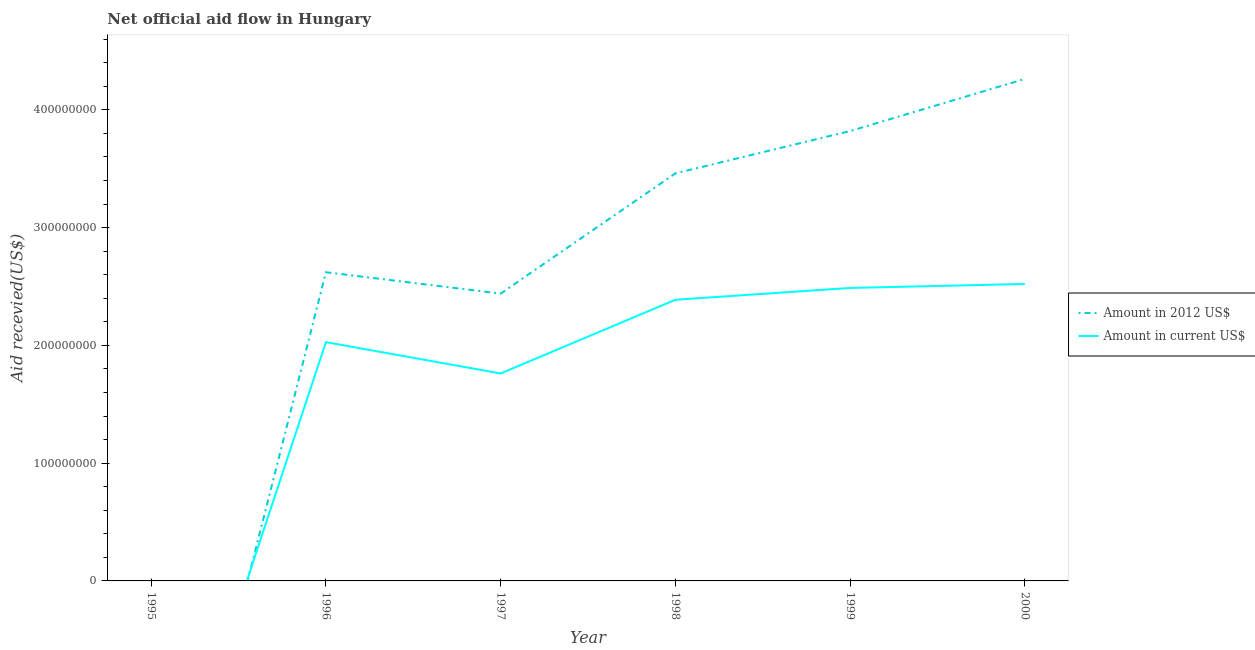How many different coloured lines are there?
Your answer should be very brief. 2. Does the line corresponding to amount of aid received(expressed in us$) intersect with the line corresponding to amount of aid received(expressed in 2012 us$)?
Keep it short and to the point. Yes. Is the number of lines equal to the number of legend labels?
Your answer should be very brief. No. What is the amount of aid received(expressed in us$) in 1999?
Offer a very short reply. 2.49e+08. Across all years, what is the maximum amount of aid received(expressed in 2012 us$)?
Give a very brief answer. 4.26e+08. In which year was the amount of aid received(expressed in us$) maximum?
Your answer should be compact. 2000. What is the total amount of aid received(expressed in 2012 us$) in the graph?
Your response must be concise. 1.66e+09. What is the difference between the amount of aid received(expressed in us$) in 1997 and that in 1999?
Your answer should be compact. -7.26e+07. What is the difference between the amount of aid received(expressed in 2012 us$) in 1997 and the amount of aid received(expressed in us$) in 2000?
Provide a short and direct response. -8.18e+06. What is the average amount of aid received(expressed in 2012 us$) per year?
Provide a short and direct response. 2.77e+08. In the year 1996, what is the difference between the amount of aid received(expressed in us$) and amount of aid received(expressed in 2012 us$)?
Give a very brief answer. -5.94e+07. What is the ratio of the amount of aid received(expressed in us$) in 1997 to that in 2000?
Your answer should be compact. 0.7. Is the difference between the amount of aid received(expressed in 2012 us$) in 1996 and 1999 greater than the difference between the amount of aid received(expressed in us$) in 1996 and 1999?
Ensure brevity in your answer.  No. What is the difference between the highest and the second highest amount of aid received(expressed in 2012 us$)?
Offer a terse response. 4.42e+07. What is the difference between the highest and the lowest amount of aid received(expressed in 2012 us$)?
Provide a succinct answer. 4.26e+08. Does the amount of aid received(expressed in 2012 us$) monotonically increase over the years?
Make the answer very short. No. Is the amount of aid received(expressed in 2012 us$) strictly greater than the amount of aid received(expressed in us$) over the years?
Offer a very short reply. No. How many years are there in the graph?
Give a very brief answer. 6. What is the difference between two consecutive major ticks on the Y-axis?
Your answer should be compact. 1.00e+08. Does the graph contain any zero values?
Provide a short and direct response. Yes. What is the title of the graph?
Give a very brief answer. Net official aid flow in Hungary. Does "UN agencies" appear as one of the legend labels in the graph?
Offer a very short reply. No. What is the label or title of the X-axis?
Make the answer very short. Year. What is the label or title of the Y-axis?
Keep it short and to the point. Aid recevied(US$). What is the Aid recevied(US$) in Amount in 2012 US$ in 1996?
Your response must be concise. 2.62e+08. What is the Aid recevied(US$) of Amount in current US$ in 1996?
Give a very brief answer. 2.03e+08. What is the Aid recevied(US$) in Amount in 2012 US$ in 1997?
Offer a very short reply. 2.44e+08. What is the Aid recevied(US$) of Amount in current US$ in 1997?
Your answer should be very brief. 1.76e+08. What is the Aid recevied(US$) in Amount in 2012 US$ in 1998?
Your answer should be very brief. 3.46e+08. What is the Aid recevied(US$) in Amount in current US$ in 1998?
Make the answer very short. 2.39e+08. What is the Aid recevied(US$) of Amount in 2012 US$ in 1999?
Your response must be concise. 3.82e+08. What is the Aid recevied(US$) in Amount in current US$ in 1999?
Your response must be concise. 2.49e+08. What is the Aid recevied(US$) in Amount in 2012 US$ in 2000?
Provide a short and direct response. 4.26e+08. What is the Aid recevied(US$) in Amount in current US$ in 2000?
Provide a short and direct response. 2.52e+08. Across all years, what is the maximum Aid recevied(US$) in Amount in 2012 US$?
Ensure brevity in your answer.  4.26e+08. Across all years, what is the maximum Aid recevied(US$) of Amount in current US$?
Offer a very short reply. 2.52e+08. Across all years, what is the minimum Aid recevied(US$) in Amount in current US$?
Give a very brief answer. 0. What is the total Aid recevied(US$) in Amount in 2012 US$ in the graph?
Make the answer very short. 1.66e+09. What is the total Aid recevied(US$) of Amount in current US$ in the graph?
Provide a short and direct response. 1.12e+09. What is the difference between the Aid recevied(US$) of Amount in 2012 US$ in 1996 and that in 1997?
Keep it short and to the point. 1.81e+07. What is the difference between the Aid recevied(US$) in Amount in current US$ in 1996 and that in 1997?
Give a very brief answer. 2.66e+07. What is the difference between the Aid recevied(US$) in Amount in 2012 US$ in 1996 and that in 1998?
Your response must be concise. -8.40e+07. What is the difference between the Aid recevied(US$) in Amount in current US$ in 1996 and that in 1998?
Keep it short and to the point. -3.60e+07. What is the difference between the Aid recevied(US$) of Amount in 2012 US$ in 1996 and that in 1999?
Your response must be concise. -1.20e+08. What is the difference between the Aid recevied(US$) of Amount in current US$ in 1996 and that in 1999?
Offer a very short reply. -4.60e+07. What is the difference between the Aid recevied(US$) in Amount in 2012 US$ in 1996 and that in 2000?
Your answer should be compact. -1.64e+08. What is the difference between the Aid recevied(US$) of Amount in current US$ in 1996 and that in 2000?
Ensure brevity in your answer.  -4.94e+07. What is the difference between the Aid recevied(US$) of Amount in 2012 US$ in 1997 and that in 1998?
Give a very brief answer. -1.02e+08. What is the difference between the Aid recevied(US$) of Amount in current US$ in 1997 and that in 1998?
Your answer should be compact. -6.26e+07. What is the difference between the Aid recevied(US$) of Amount in 2012 US$ in 1997 and that in 1999?
Give a very brief answer. -1.38e+08. What is the difference between the Aid recevied(US$) in Amount in current US$ in 1997 and that in 1999?
Offer a terse response. -7.26e+07. What is the difference between the Aid recevied(US$) of Amount in 2012 US$ in 1997 and that in 2000?
Offer a terse response. -1.82e+08. What is the difference between the Aid recevied(US$) in Amount in current US$ in 1997 and that in 2000?
Your response must be concise. -7.60e+07. What is the difference between the Aid recevied(US$) of Amount in 2012 US$ in 1998 and that in 1999?
Keep it short and to the point. -3.59e+07. What is the difference between the Aid recevied(US$) in Amount in current US$ in 1998 and that in 1999?
Offer a very short reply. -1.00e+07. What is the difference between the Aid recevied(US$) of Amount in 2012 US$ in 1998 and that in 2000?
Offer a very short reply. -8.02e+07. What is the difference between the Aid recevied(US$) of Amount in current US$ in 1998 and that in 2000?
Keep it short and to the point. -1.34e+07. What is the difference between the Aid recevied(US$) in Amount in 2012 US$ in 1999 and that in 2000?
Give a very brief answer. -4.42e+07. What is the difference between the Aid recevied(US$) in Amount in current US$ in 1999 and that in 2000?
Offer a terse response. -3.39e+06. What is the difference between the Aid recevied(US$) of Amount in 2012 US$ in 1996 and the Aid recevied(US$) of Amount in current US$ in 1997?
Offer a very short reply. 8.60e+07. What is the difference between the Aid recevied(US$) of Amount in 2012 US$ in 1996 and the Aid recevied(US$) of Amount in current US$ in 1998?
Keep it short and to the point. 2.34e+07. What is the difference between the Aid recevied(US$) of Amount in 2012 US$ in 1996 and the Aid recevied(US$) of Amount in current US$ in 1999?
Give a very brief answer. 1.33e+07. What is the difference between the Aid recevied(US$) in Amount in 2012 US$ in 1996 and the Aid recevied(US$) in Amount in current US$ in 2000?
Your answer should be compact. 9.95e+06. What is the difference between the Aid recevied(US$) of Amount in 2012 US$ in 1997 and the Aid recevied(US$) of Amount in current US$ in 1998?
Give a very brief answer. 5.24e+06. What is the difference between the Aid recevied(US$) in Amount in 2012 US$ in 1997 and the Aid recevied(US$) in Amount in current US$ in 1999?
Provide a short and direct response. -4.79e+06. What is the difference between the Aid recevied(US$) in Amount in 2012 US$ in 1997 and the Aid recevied(US$) in Amount in current US$ in 2000?
Your answer should be very brief. -8.18e+06. What is the difference between the Aid recevied(US$) of Amount in 2012 US$ in 1998 and the Aid recevied(US$) of Amount in current US$ in 1999?
Keep it short and to the point. 9.73e+07. What is the difference between the Aid recevied(US$) in Amount in 2012 US$ in 1998 and the Aid recevied(US$) in Amount in current US$ in 2000?
Make the answer very short. 9.39e+07. What is the difference between the Aid recevied(US$) in Amount in 2012 US$ in 1999 and the Aid recevied(US$) in Amount in current US$ in 2000?
Offer a very short reply. 1.30e+08. What is the average Aid recevied(US$) of Amount in 2012 US$ per year?
Your answer should be very brief. 2.77e+08. What is the average Aid recevied(US$) of Amount in current US$ per year?
Your answer should be very brief. 1.86e+08. In the year 1996, what is the difference between the Aid recevied(US$) in Amount in 2012 US$ and Aid recevied(US$) in Amount in current US$?
Give a very brief answer. 5.94e+07. In the year 1997, what is the difference between the Aid recevied(US$) of Amount in 2012 US$ and Aid recevied(US$) of Amount in current US$?
Provide a short and direct response. 6.78e+07. In the year 1998, what is the difference between the Aid recevied(US$) in Amount in 2012 US$ and Aid recevied(US$) in Amount in current US$?
Keep it short and to the point. 1.07e+08. In the year 1999, what is the difference between the Aid recevied(US$) of Amount in 2012 US$ and Aid recevied(US$) of Amount in current US$?
Provide a succinct answer. 1.33e+08. In the year 2000, what is the difference between the Aid recevied(US$) in Amount in 2012 US$ and Aid recevied(US$) in Amount in current US$?
Give a very brief answer. 1.74e+08. What is the ratio of the Aid recevied(US$) in Amount in 2012 US$ in 1996 to that in 1997?
Provide a succinct answer. 1.07. What is the ratio of the Aid recevied(US$) of Amount in current US$ in 1996 to that in 1997?
Provide a short and direct response. 1.15. What is the ratio of the Aid recevied(US$) in Amount in 2012 US$ in 1996 to that in 1998?
Give a very brief answer. 0.76. What is the ratio of the Aid recevied(US$) of Amount in current US$ in 1996 to that in 1998?
Your answer should be very brief. 0.85. What is the ratio of the Aid recevied(US$) of Amount in 2012 US$ in 1996 to that in 1999?
Ensure brevity in your answer.  0.69. What is the ratio of the Aid recevied(US$) in Amount in current US$ in 1996 to that in 1999?
Offer a very short reply. 0.81. What is the ratio of the Aid recevied(US$) of Amount in 2012 US$ in 1996 to that in 2000?
Your answer should be compact. 0.61. What is the ratio of the Aid recevied(US$) of Amount in current US$ in 1996 to that in 2000?
Provide a succinct answer. 0.8. What is the ratio of the Aid recevied(US$) of Amount in 2012 US$ in 1997 to that in 1998?
Ensure brevity in your answer.  0.7. What is the ratio of the Aid recevied(US$) of Amount in current US$ in 1997 to that in 1998?
Offer a very short reply. 0.74. What is the ratio of the Aid recevied(US$) in Amount in 2012 US$ in 1997 to that in 1999?
Give a very brief answer. 0.64. What is the ratio of the Aid recevied(US$) in Amount in current US$ in 1997 to that in 1999?
Your answer should be compact. 0.71. What is the ratio of the Aid recevied(US$) of Amount in 2012 US$ in 1997 to that in 2000?
Offer a terse response. 0.57. What is the ratio of the Aid recevied(US$) of Amount in current US$ in 1997 to that in 2000?
Keep it short and to the point. 0.7. What is the ratio of the Aid recevied(US$) in Amount in 2012 US$ in 1998 to that in 1999?
Make the answer very short. 0.91. What is the ratio of the Aid recevied(US$) in Amount in current US$ in 1998 to that in 1999?
Your answer should be very brief. 0.96. What is the ratio of the Aid recevied(US$) in Amount in 2012 US$ in 1998 to that in 2000?
Give a very brief answer. 0.81. What is the ratio of the Aid recevied(US$) of Amount in current US$ in 1998 to that in 2000?
Make the answer very short. 0.95. What is the ratio of the Aid recevied(US$) of Amount in 2012 US$ in 1999 to that in 2000?
Provide a succinct answer. 0.9. What is the ratio of the Aid recevied(US$) in Amount in current US$ in 1999 to that in 2000?
Offer a terse response. 0.99. What is the difference between the highest and the second highest Aid recevied(US$) in Amount in 2012 US$?
Your response must be concise. 4.42e+07. What is the difference between the highest and the second highest Aid recevied(US$) of Amount in current US$?
Give a very brief answer. 3.39e+06. What is the difference between the highest and the lowest Aid recevied(US$) of Amount in 2012 US$?
Ensure brevity in your answer.  4.26e+08. What is the difference between the highest and the lowest Aid recevied(US$) of Amount in current US$?
Keep it short and to the point. 2.52e+08. 